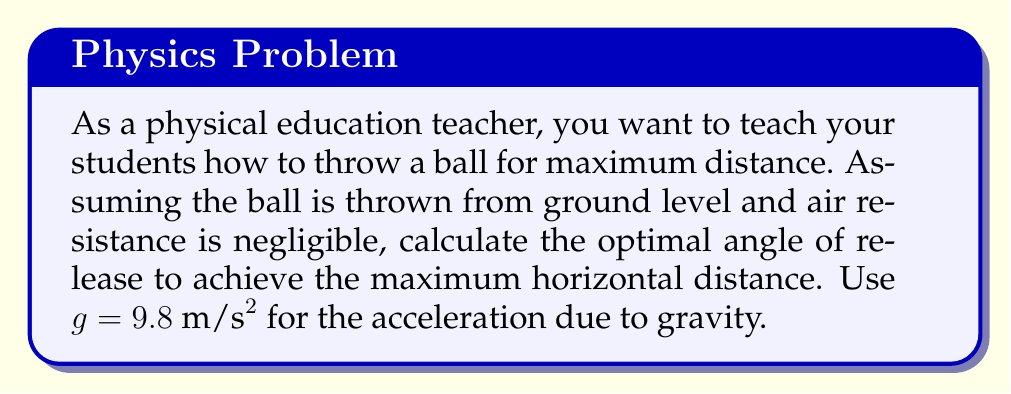Show me your answer to this math problem. To solve this problem, we need to use principles from projectile motion and optimization.

1) The range equation for a projectile launched from ground level is:

   $$R = \frac{v_0^2 \sin(2\theta)}{g}$$

   Where $R$ is the range, $v_0$ is the initial velocity, $\theta$ is the launch angle, and $g$ is the acceleration due to gravity.

2) To find the maximum range, we need to maximize $\sin(2\theta)$. The sine function reaches its maximum value of 1 when its argument is 90°.

3) Therefore:

   $$2\theta = 90°$$
   $$\theta = 45°$$

4) We can verify this by taking the derivative of $R$ with respect to $\theta$:

   $$\frac{dR}{d\theta} = \frac{v_0^2}{g} \cdot 2\cos(2\theta)$$

5) Setting this equal to zero:

   $$\frac{v_0^2}{g} \cdot 2\cos(2\theta) = 0$$
   $$\cos(2\theta) = 0$$

6) This occurs when $2\theta = 90°$, confirming our earlier result.

This result is independent of the initial velocity and the acceleration due to gravity, making it a universal principle for projectile motion in a uniform gravitational field without air resistance.
Answer: The optimal angle of release to achieve maximum horizontal distance is 45°. 